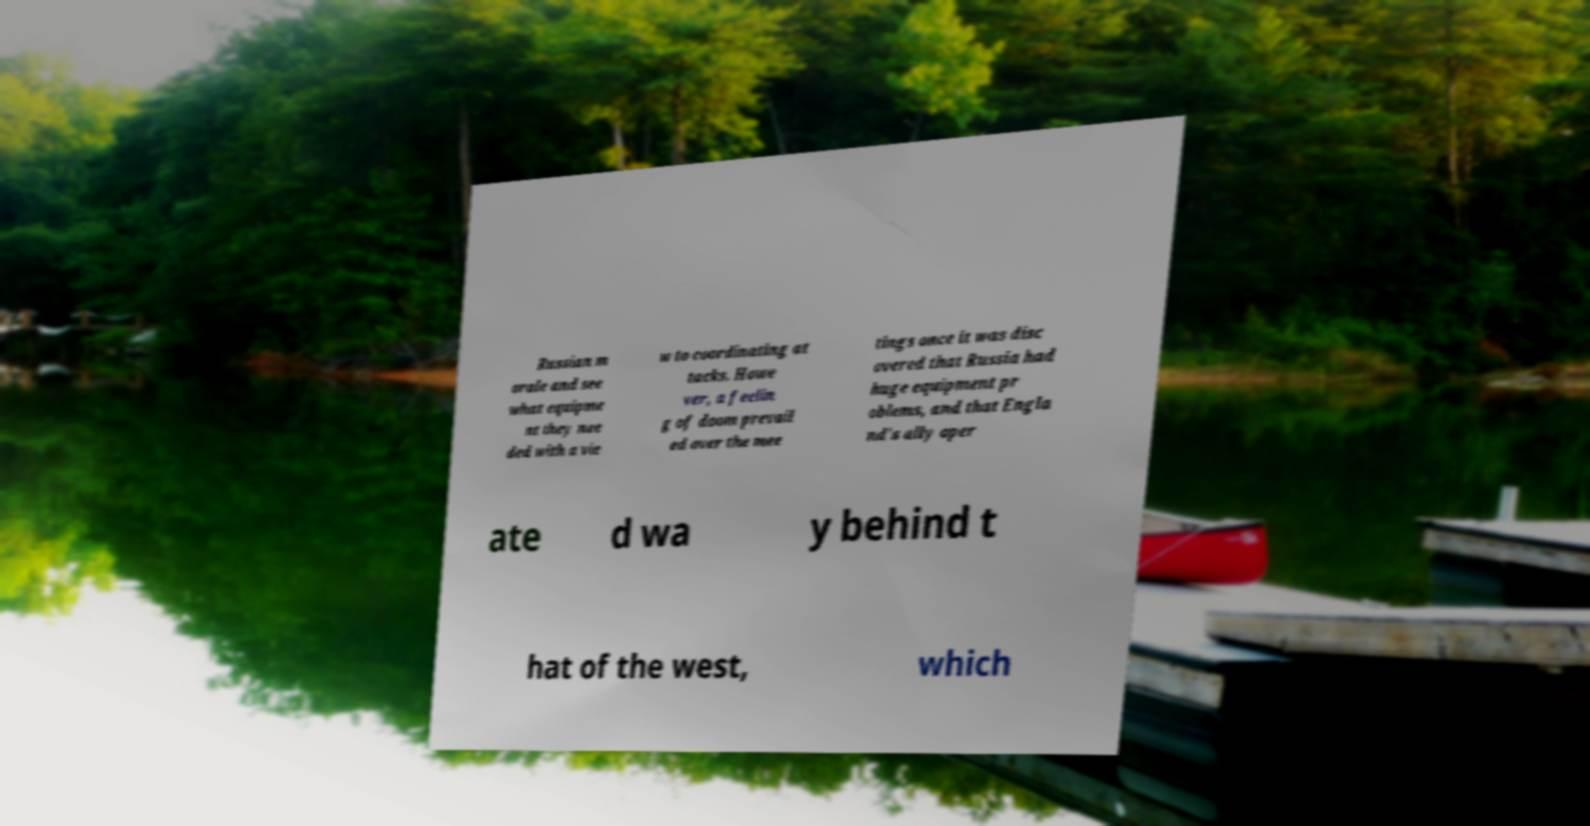There's text embedded in this image that I need extracted. Can you transcribe it verbatim? Russian m orale and see what equipme nt they nee ded with a vie w to coordinating at tacks. Howe ver, a feelin g of doom prevail ed over the mee tings once it was disc overed that Russia had huge equipment pr oblems, and that Engla nd's ally oper ate d wa y behind t hat of the west, which 